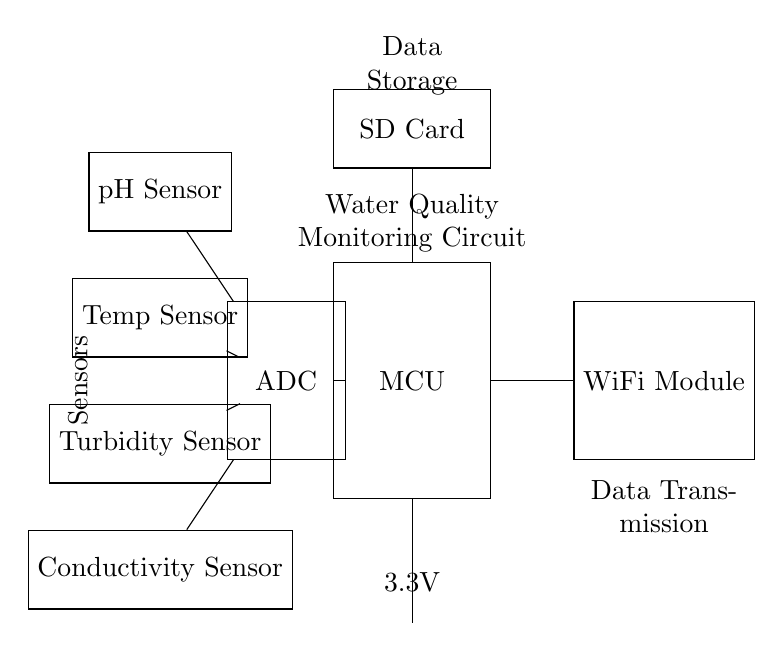What is the power supply voltage? The circuit uses a battery as the power supply, which is indicated to provide 3.3V.
Answer: 3.3V What components are used for measuring water quality? The diagram shows four sensors intended for water quality measurement: pH sensor, temperature sensor, turbidity sensor, and conductivity sensor.
Answer: pH sensor, temperature sensor, turbidity sensor, conductivity sensor Which module is responsible for data transmission? The WiFi Module is labeled in the diagram and indicates its role in transmitting collected data wirelessly.
Answer: WiFi Module How are the sensors connected to the microcontroller? The sensors (pH, temperature, turbidity, and conductivity) have direct connections to the Analog-to-Digital Converter (ADC), which is then connected to the microcontroller (MCU). This indicates a sequential data flow from sensors to processing unit.
Answer: Through the ADC What is the function of the SD card in the circuit? The SD Card is specifically labeled for data storage, indicating that it will store data collected by the microcontroller for later retrieval or analysis.
Answer: Data storage How many sensors are there in total? The circuit diagram lists a total of four sensors, each serving a different function related to water quality assessment.
Answer: Four 